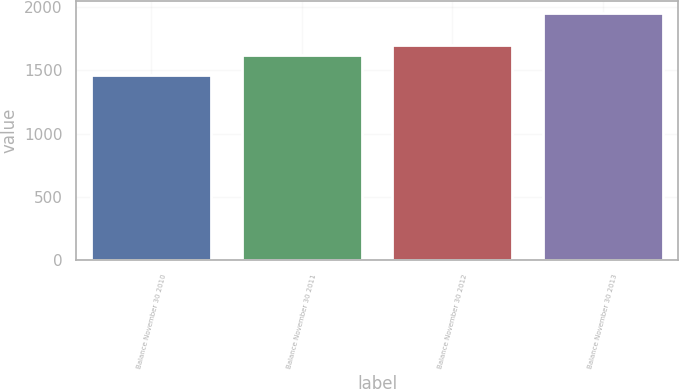Convert chart to OTSL. <chart><loc_0><loc_0><loc_500><loc_500><bar_chart><fcel>Balance November 30 2010<fcel>Balance November 30 2011<fcel>Balance November 30 2012<fcel>Balance November 30 2013<nl><fcel>1462.7<fcel>1618.5<fcel>1700.2<fcel>1947.7<nl></chart> 